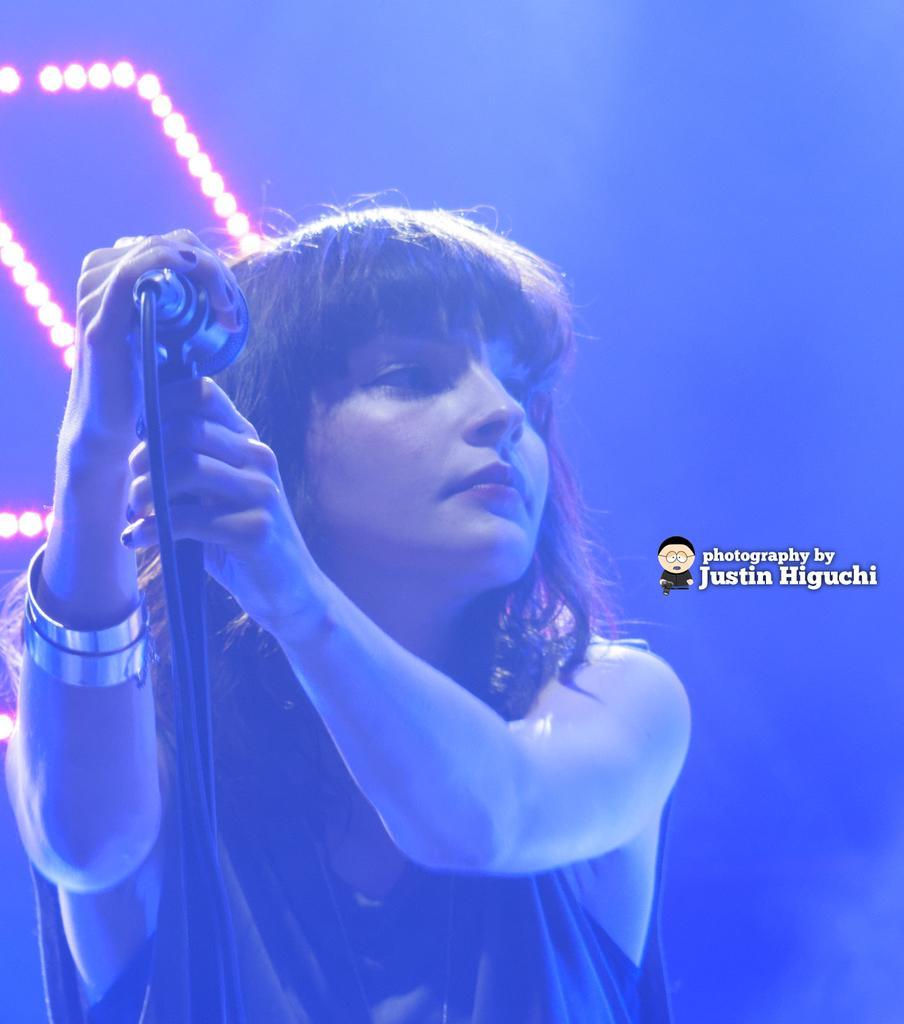Describe this image in one or two sentences. In the middle of the image a woman is standing and holding a microphone. Behind her there are some lights. 